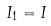<formula> <loc_0><loc_0><loc_500><loc_500>I _ { 1 } = I</formula> 